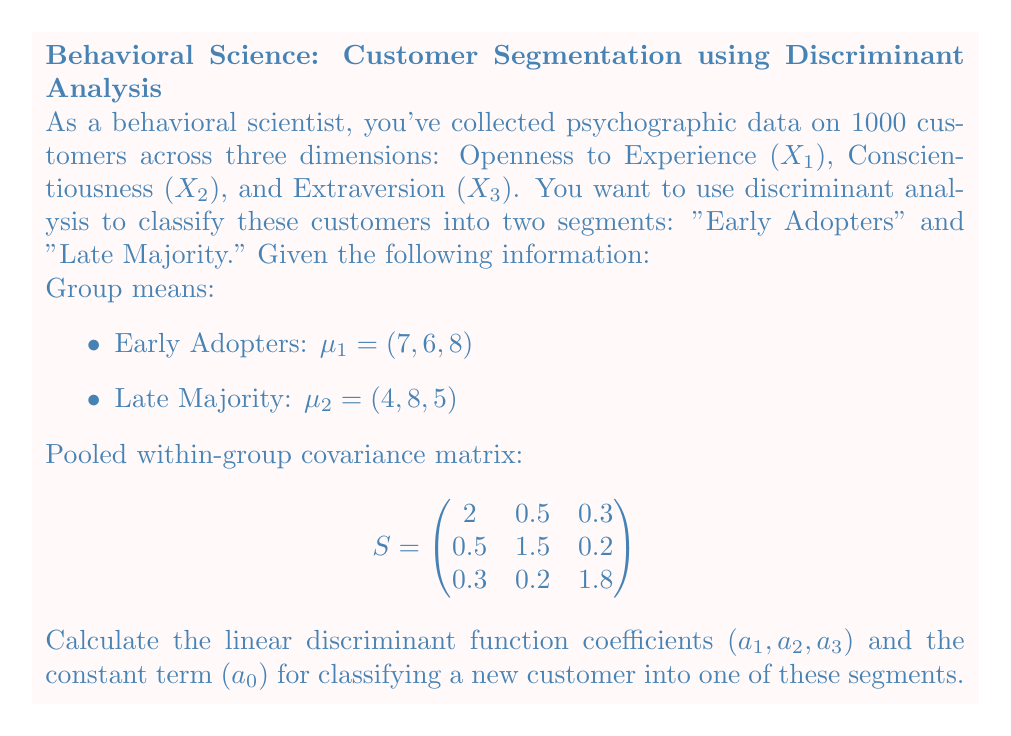Could you help me with this problem? To solve this problem, we'll follow these steps:

1. Calculate the difference between group means:
$\mathbf{d} = \mu_1 - \mu_2 = (7-4, 6-8, 8-5) = (3, -2, 3)$

2. Calculate the linear discriminant function coefficients:
$\mathbf{a} = S^{-1}\mathbf{d}$

To find $S^{-1}$, we need to invert the pooled within-group covariance matrix:

$$S^{-1} = \begin{pmatrix}
0.5263 & -0.1754 & -0.0877 \\
-0.1754 & 0.7018 & -0.0351 \\
-0.0877 & -0.0351 & 0.5614
\end{pmatrix}$$

Now, we can calculate $\mathbf{a}$:

$$\mathbf{a} = \begin{pmatrix}
0.5263 & -0.1754 & -0.0877 \\
-0.1754 & 0.7018 & -0.0351 \\
-0.0877 & -0.0351 & 0.5614
\end{pmatrix} \begin{pmatrix}
3 \\
-2 \\
3
\end{pmatrix}$$

$$\mathbf{a} = \begin{pmatrix}
1.4035 \\
-1.2281 \\
1.5789
\end{pmatrix}$$

So, $a_1 = 1.4035$, $a_2 = -1.2281$, and $a_3 = 1.5789$.

3. Calculate the constant term $a_0$:
$a_0 = -\frac{1}{2}\mathbf{a}^T(\mu_1 + \mu_2)$

$$a_0 = -\frac{1}{2}(1.4035, -1.2281, 1.5789)\begin{pmatrix}
11 \\
14 \\
13
\end{pmatrix}$$

$$a_0 = -\frac{1}{2}(15.4385 - 17.1934 + 20.5257) = -9.3854$$

The linear discriminant function is:
$f(\mathbf{x}) = a_0 + a_1x_1 + a_2x_2 + a_3x_3$

Where $\mathbf{x} = (x_1, x_2, x_3)$ represents a new customer's psychographic data.
Answer: $a_1 = 1.4035$, $a_2 = -1.2281$, $a_3 = 1.5789$, $a_0 = -9.3854$ 